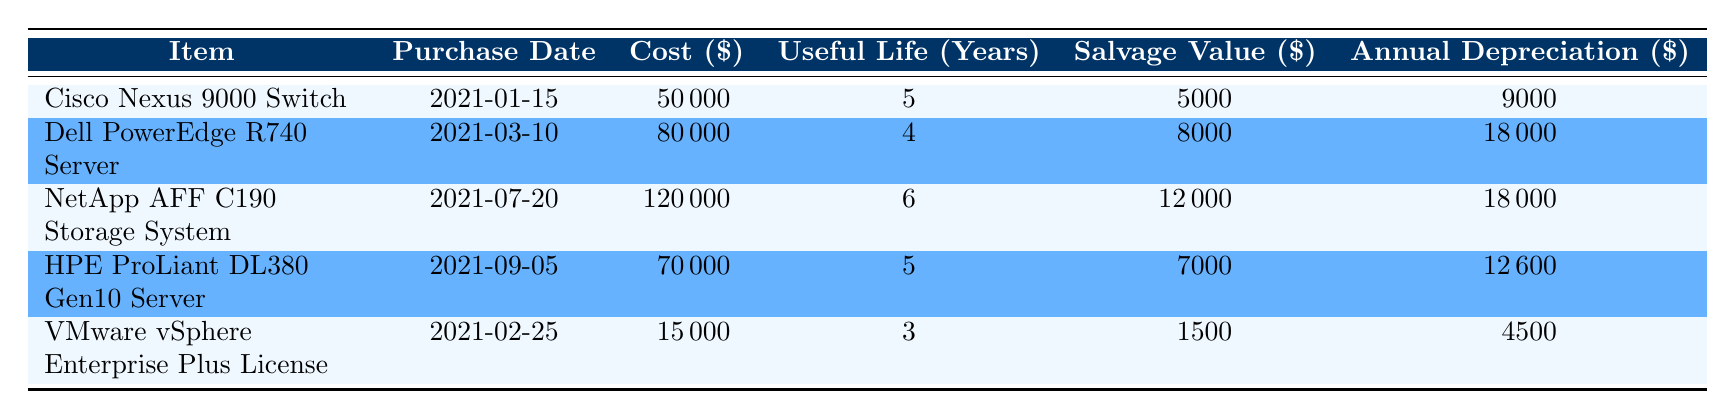What is the purchase date of the Dell PowerEdge R740 Server? The table shows the purchase date for each hardware investment. For the Dell PowerEdge R740 Server, the purchase date is listed directly in the table.
Answer: 2021-03-10 How much will the annual depreciation be for the NetApp AFF C190 Storage System? The annual depreciation for the NetApp AFF C190 Storage System is provided in the column labeled "Annual Depreciation ($)." The table indicates this value directly for the item.
Answer: 18000 Which item has the shortest useful life? The useful life of each item is presented in the table. The VMware vSphere Enterprise Plus License has a useful life of 3 years, which is the shortest compared to the others.
Answer: VMware vSphere Enterprise Plus License What is the total cost of all hardware investments? To find the total cost, we sum the cost of all items listed in the table: 50000 + 80000 + 120000 + 70000 + 15000 = 350000.
Answer: 350000 Is the annual depreciation for the Cisco Nexus 9000 Switch greater than that of the HPE ProLiant DL380 Gen10 Server? The table provides the annual depreciation figures for both items: Cisco Nexus 9000 Switch has 9000, while HPE ProLiant DL380 Gen10 Server has 12600. Since 9000 is less than 12600, the statement is false.
Answer: No What is the average salvage value of the hardware investments? First, sum the salvage values: 5000 + 8000 + 12000 + 7000 + 1500 = 34500. Next, divide by the number of items (5): 34500 / 5 = 6900.
Answer: 6900 Which hardware investment has the highest cost? By reviewing the cost column, the NetApp AFF C190 Storage System has the highest cost at 120000, compared to other items in the table.
Answer: NetApp AFF C190 Storage System If we consider only the hardware items with a useful life of 5 years, what will be their total annual depreciation? The items with a useful life of 5 years are the Cisco Nexus 9000 Switch and HPE ProLiant DL380 Gen10 Server. Their annual depreciations are 9000 and 12600, respectively. Summing these gives: 9000 + 12600 = 21600.
Answer: 21600 What percentage of the total cost does the salvage value of the Dell PowerEdge R740 Server represent? The salvage value of the Dell PowerEdge R740 Server is 8000, and the total cost is previously calculated as 350000. The percentage is calculated as (8000 / 350000) * 100 = 2.29%.
Answer: 2.29% 